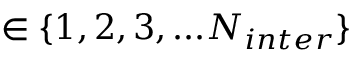Convert formula to latex. <formula><loc_0><loc_0><loc_500><loc_500>\in \{ 1 , 2 , 3 , \dots N _ { i n t e r } \}</formula> 